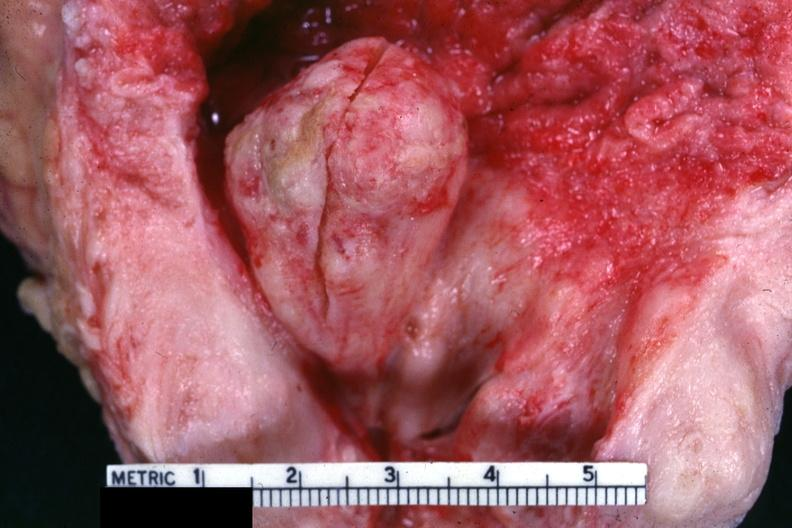s heart present?
Answer the question using a single word or phrase. No 